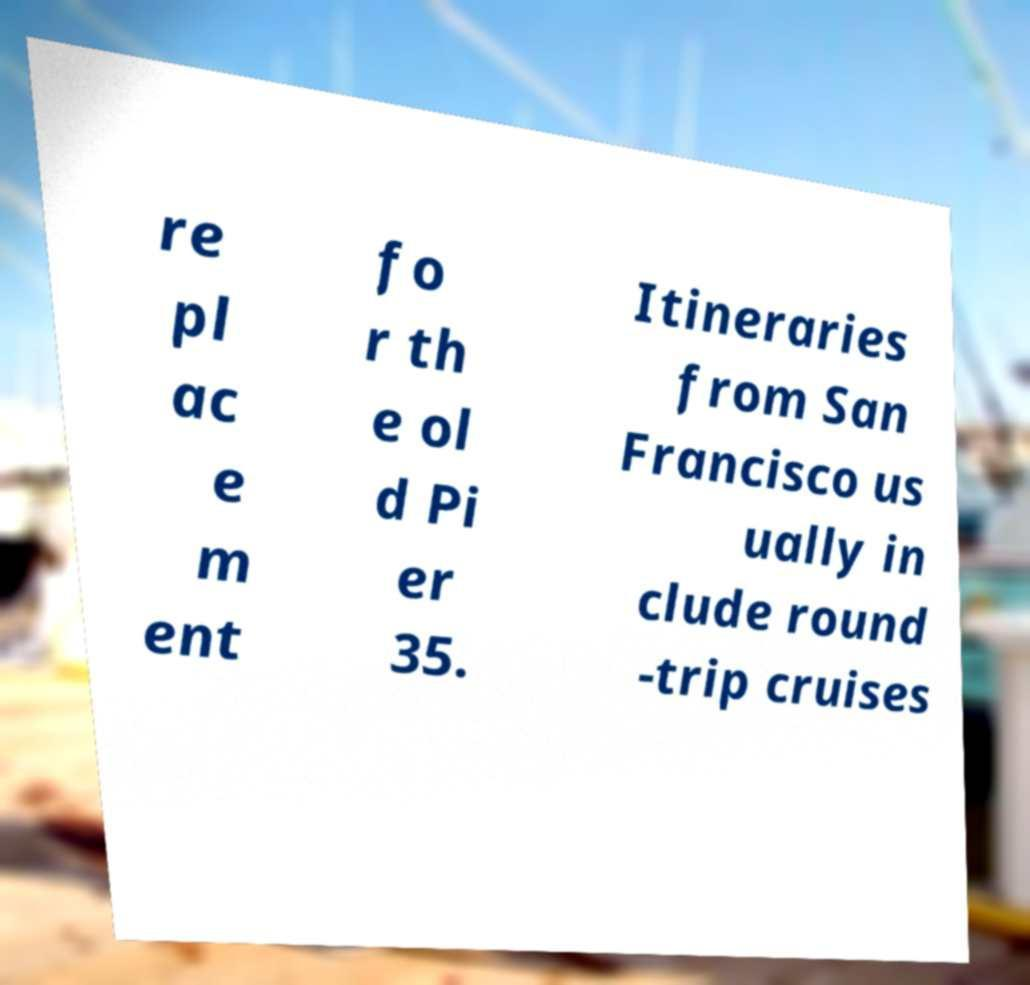Could you assist in decoding the text presented in this image and type it out clearly? re pl ac e m ent fo r th e ol d Pi er 35. Itineraries from San Francisco us ually in clude round -trip cruises 